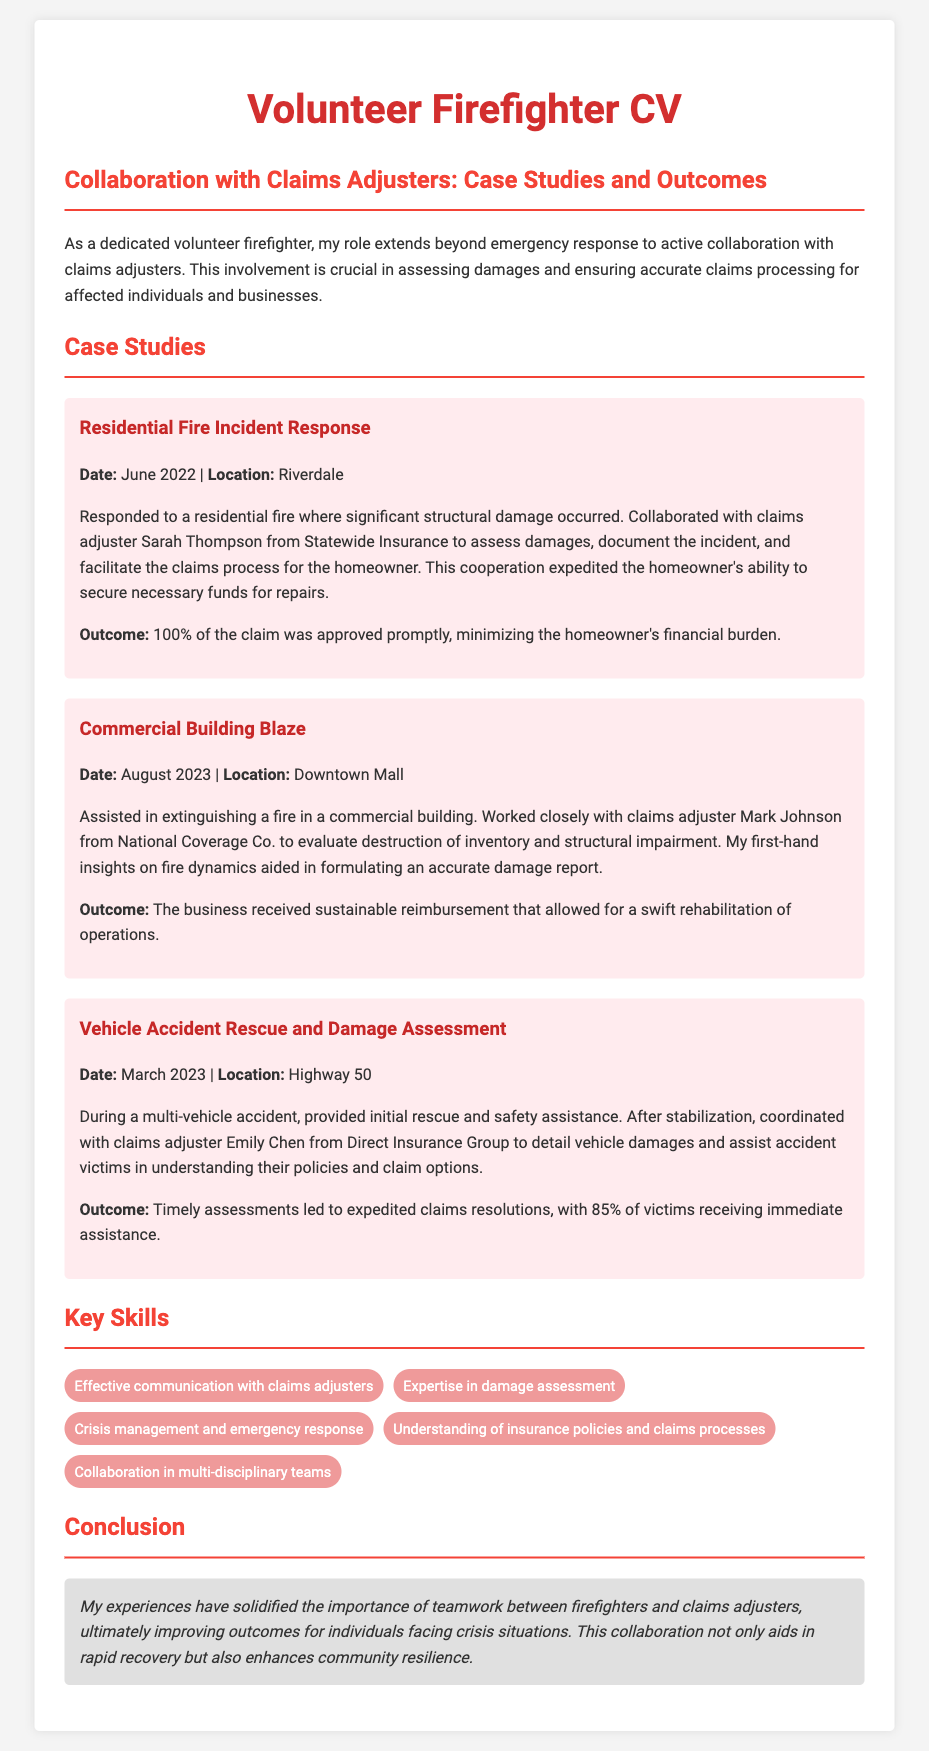what is the date of the residential fire incident? The date listed for the residential fire incident is June 2022.
Answer: June 2022 who was the claims adjuster for the commercial building blaze? The claims adjuster for the commercial building blaze was Mark Johnson.
Answer: Mark Johnson what percentage of the claim was approved for the residential fire? The document states that 100% of the claim was approved promptly for the residential fire.
Answer: 100% what was the location of the vehicle accident rescue? The location of the vehicle accident rescue is Highway 50.
Answer: Highway 50 how many victims received immediate assistance after the vehicle accident? The document mentions that 85% of victims received immediate assistance.
Answer: 85% what is a key skill mentioned related to collaborating with claims adjusters? Effective communication with claims adjusters is mentioned as a key skill.
Answer: Effective communication with claims adjusters what type of incidents does the CV focus on in relation to claims adjusters? The CV focuses on emergency incidents where assessments of damages are made in collaboration with claims adjusters.
Answer: Emergency incidents who was the claims adjuster for the residential fire incident? The claims adjuster for the residential fire incident was Sarah Thompson.
Answer: Sarah Thompson what was the outcome of the commercial building blaze assessment? The outcome was that the business received sustainable reimbursement for swift rehabilitation of operations.
Answer: Sustainable reimbursement 